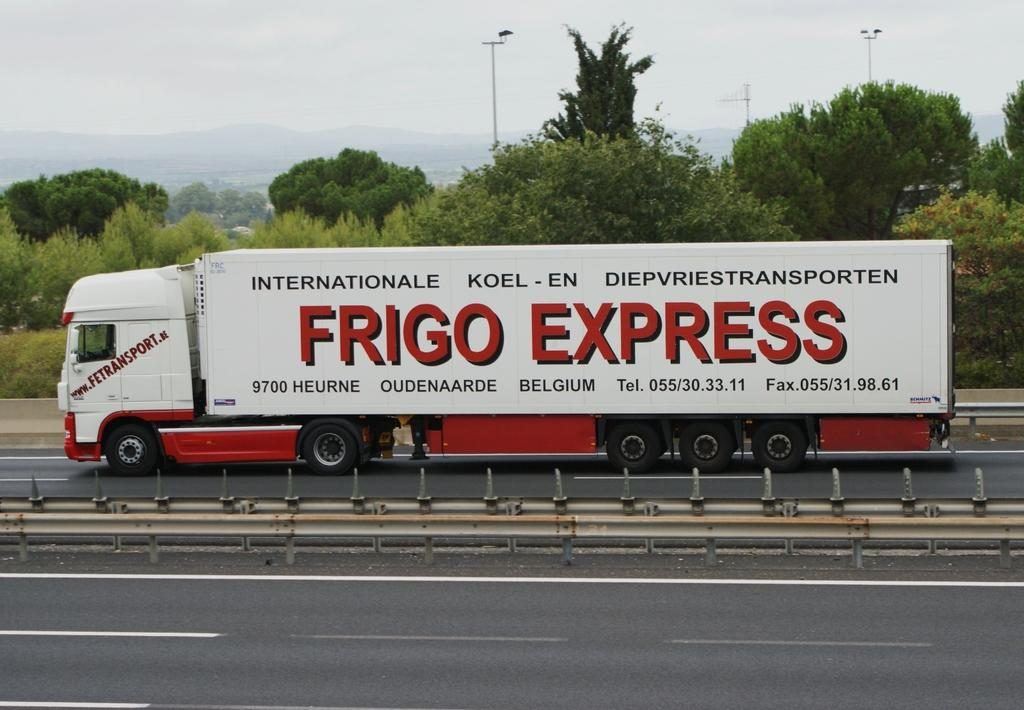What type of barrier can be seen in the image? There is a fence in the image. What is located on the road in the image? There is a truck on the road in the image. What can be seen in the distance in the image? There are trees, poles, and hills in the background of the image. What type of chain is hanging from the truck in the image? There is no chain hanging from the truck in the image. Can you see a river flowing in the background of the image? There is no river visible in the image; it features trees, poles, and hills in the background. 